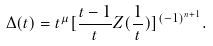<formula> <loc_0><loc_0><loc_500><loc_500>\Delta ( t ) = t ^ { \mu } [ \frac { t - 1 } { t } Z ( \frac { 1 } { t } ) ] ^ { ( - 1 ) ^ { n + 1 } } .</formula> 